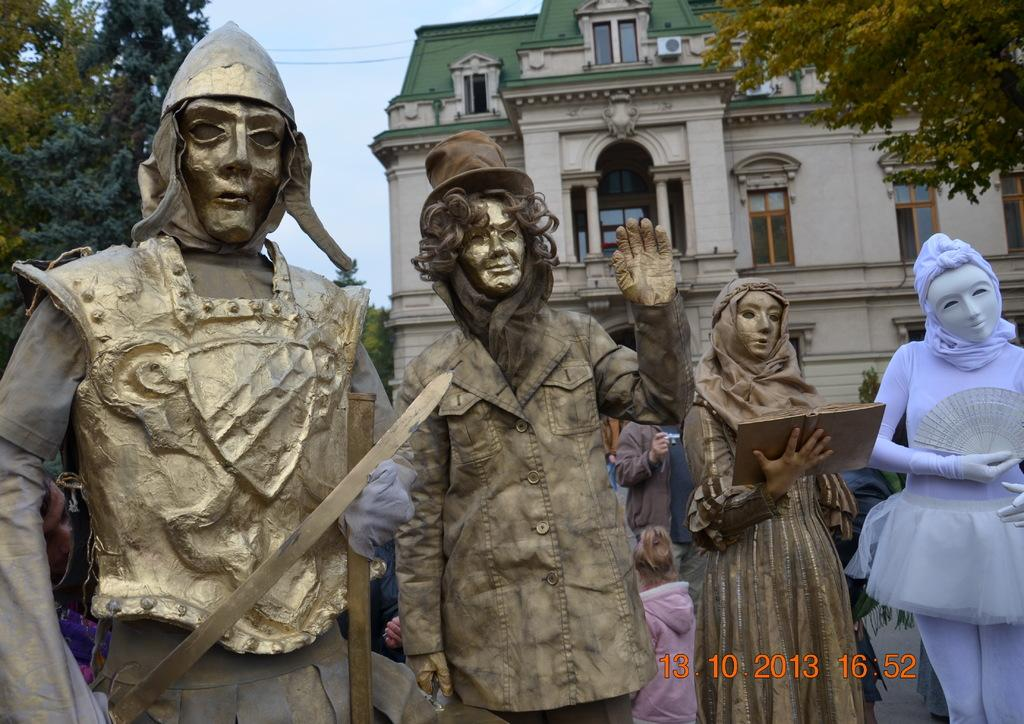What type of objects are depicted in the image? There are statues of persons in the image. What colors can be seen on the statues? The statues have gold, brown, and purple colors. What can be seen in the background of the image? There are persons, trees, a building, windows, and the sky visible in the background of the image. Can you see a finger running across the spade in the image? There is no finger or spade present in the image. 